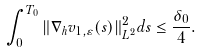Convert formula to latex. <formula><loc_0><loc_0><loc_500><loc_500>\int _ { 0 } ^ { T _ { 0 } } \| \nabla _ { h } v _ { 1 , \varepsilon } ( s ) \| _ { L ^ { 2 } } ^ { 2 } d s \leq \frac { \delta _ { 0 } } { 4 } .</formula> 